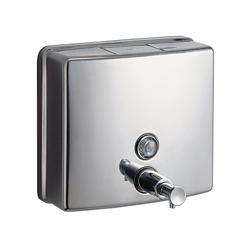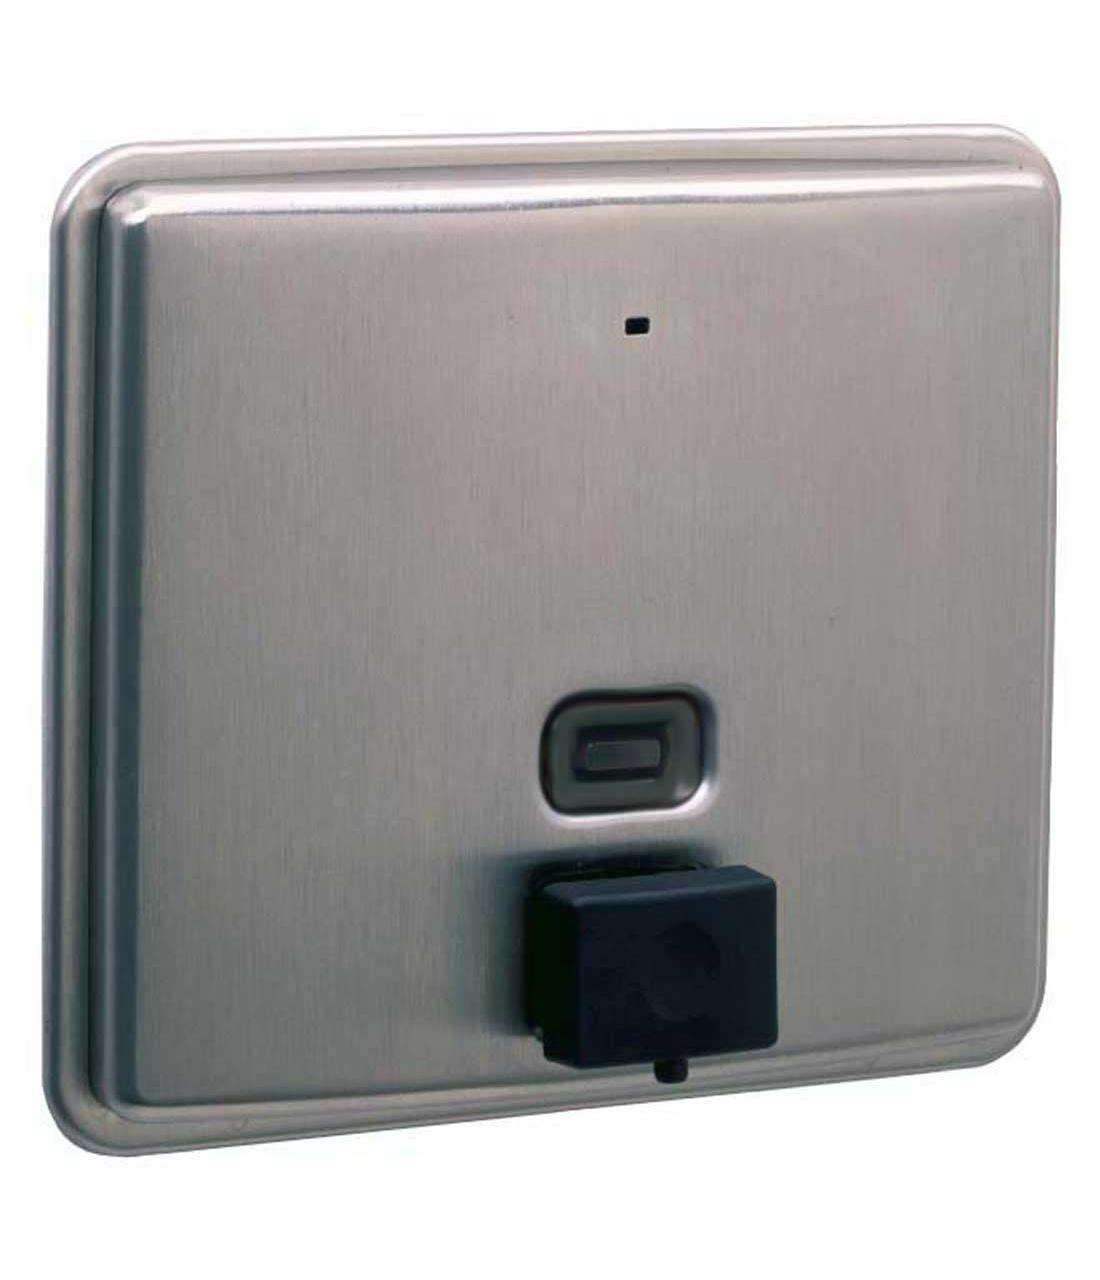The first image is the image on the left, the second image is the image on the right. Evaluate the accuracy of this statement regarding the images: "The left and right image contains the same number of metal square soap dispenser.". Is it true? Answer yes or no. Yes. The first image is the image on the left, the second image is the image on the right. Assess this claim about the two images: "The dispenser on the left has a chrome push-button that extends out, and the dispenser on the right has a flat black rectangular button.". Correct or not? Answer yes or no. Yes. 